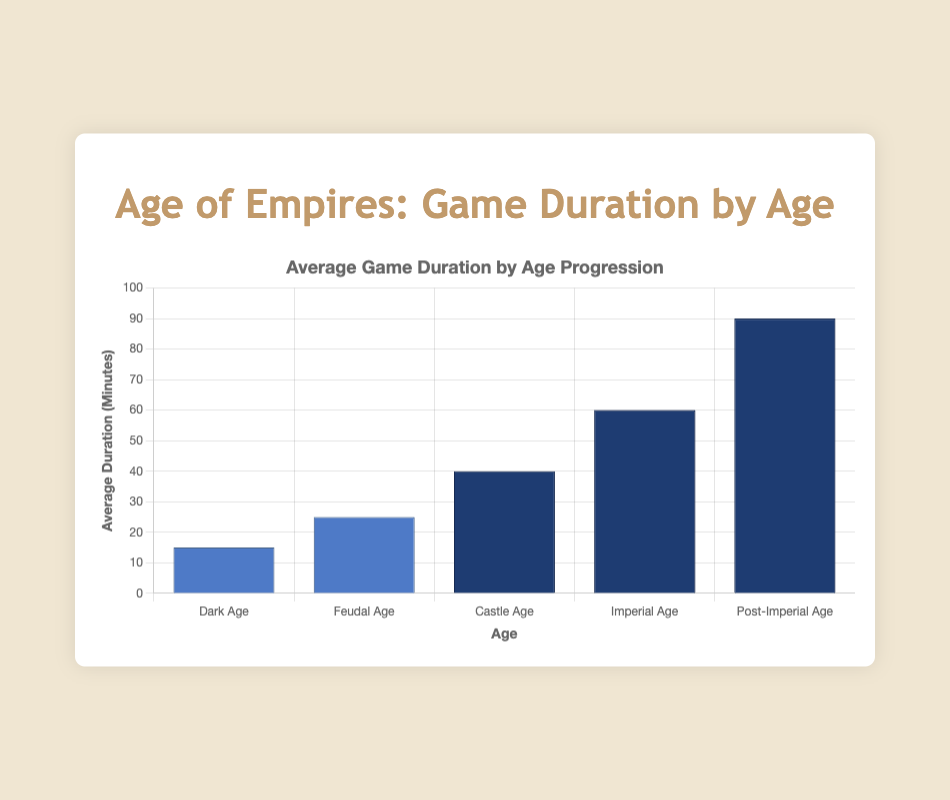Which age has the longest average game duration? The Post-Imperial Age has the longest bar, indicating it has the longest average game duration.
Answer: Post-Imperial Age What is the difference in average game duration between the Dark Age and the Imperial Age? The average duration for the Dark Age is 15 minutes and for the Imperial Age is 60 minutes. The difference is 60 - 15 = 45 minutes.
Answer: 45 minutes How does the average game duration change from the Feudal Age to the Castle Age? The average duration increases from 25 minutes in the Feudal Age to 40 minutes in the Castle Age.
Answer: Increases Which age sees the most significant increase in average game duration from the previous age? The increase from the Imperial Age to the Post-Imperial Age is 30 minutes (60 to 90), which is the largest compared to other transitions.
Answer: Post-Imperial Age What is the average of the average game durations across all ages? Sum the durations across all ages (15 + 25 + 40 + 60 + 90 = 230) and divide by the number of ages (5). The average is 230/5 = 46 minutes.
Answer: 46 minutes Between which ages does the average game duration increase by more than 20 minutes? Between the Castle Age (40 minutes) and the Imperial Age (60 minutes) with an increase of 20 minutes, and between the Imperial Age (60 minutes) and the Post-Imperial Age (90 minutes) with an increase of 30 minutes.
Answer: Castle Age to Imperial Age and Imperial Age to Post-Imperial Age Which two ages have the closest average game durations? The Feudal Age (25 minutes) and the Castle Age (40 minutes) differ by 15 minutes, which is the smallest difference among adjacent ages.
Answer: Feudal Age and Castle Age What is the total combined average game duration for the Feudal, Castle, and Imperial Ages? Sum the average durations for these ages: 25 + 40 + 60 = 125 minutes.
Answer: 125 minutes 